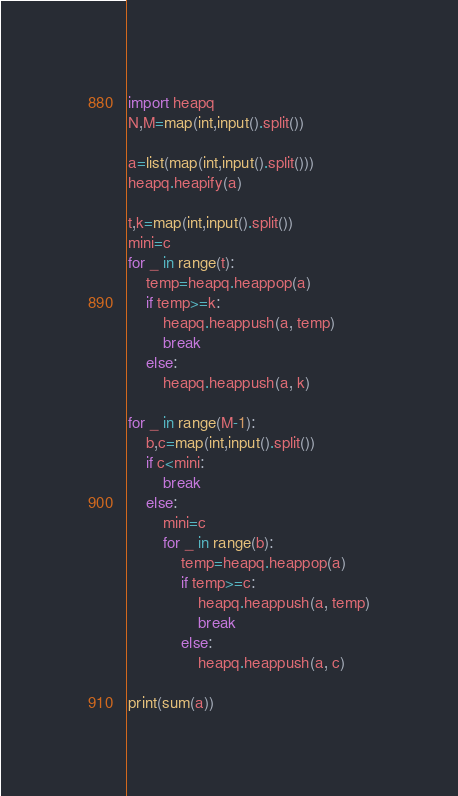Convert code to text. <code><loc_0><loc_0><loc_500><loc_500><_Python_>import heapq
N,M=map(int,input().split())

a=list(map(int,input().split()))
heapq.heapify(a)

t,k=map(int,input().split())
mini=c
for _ in range(t):
    temp=heapq.heappop(a)
    if temp>=k:
        heapq.heappush(a, temp)
        break
    else:
        heapq.heappush(a, k)

for _ in range(M-1):
    b,c=map(int,input().split())
    if c<mini:
        break
    else:
        mini=c
        for _ in range(b):
            temp=heapq.heappop(a)
            if temp>=c:
                heapq.heappush(a, temp)
                break
            else:
                heapq.heappush(a, c)
            
print(sum(a))</code> 